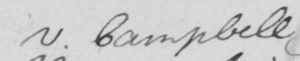Transcribe the text shown in this historical manuscript line. v . Campbell 